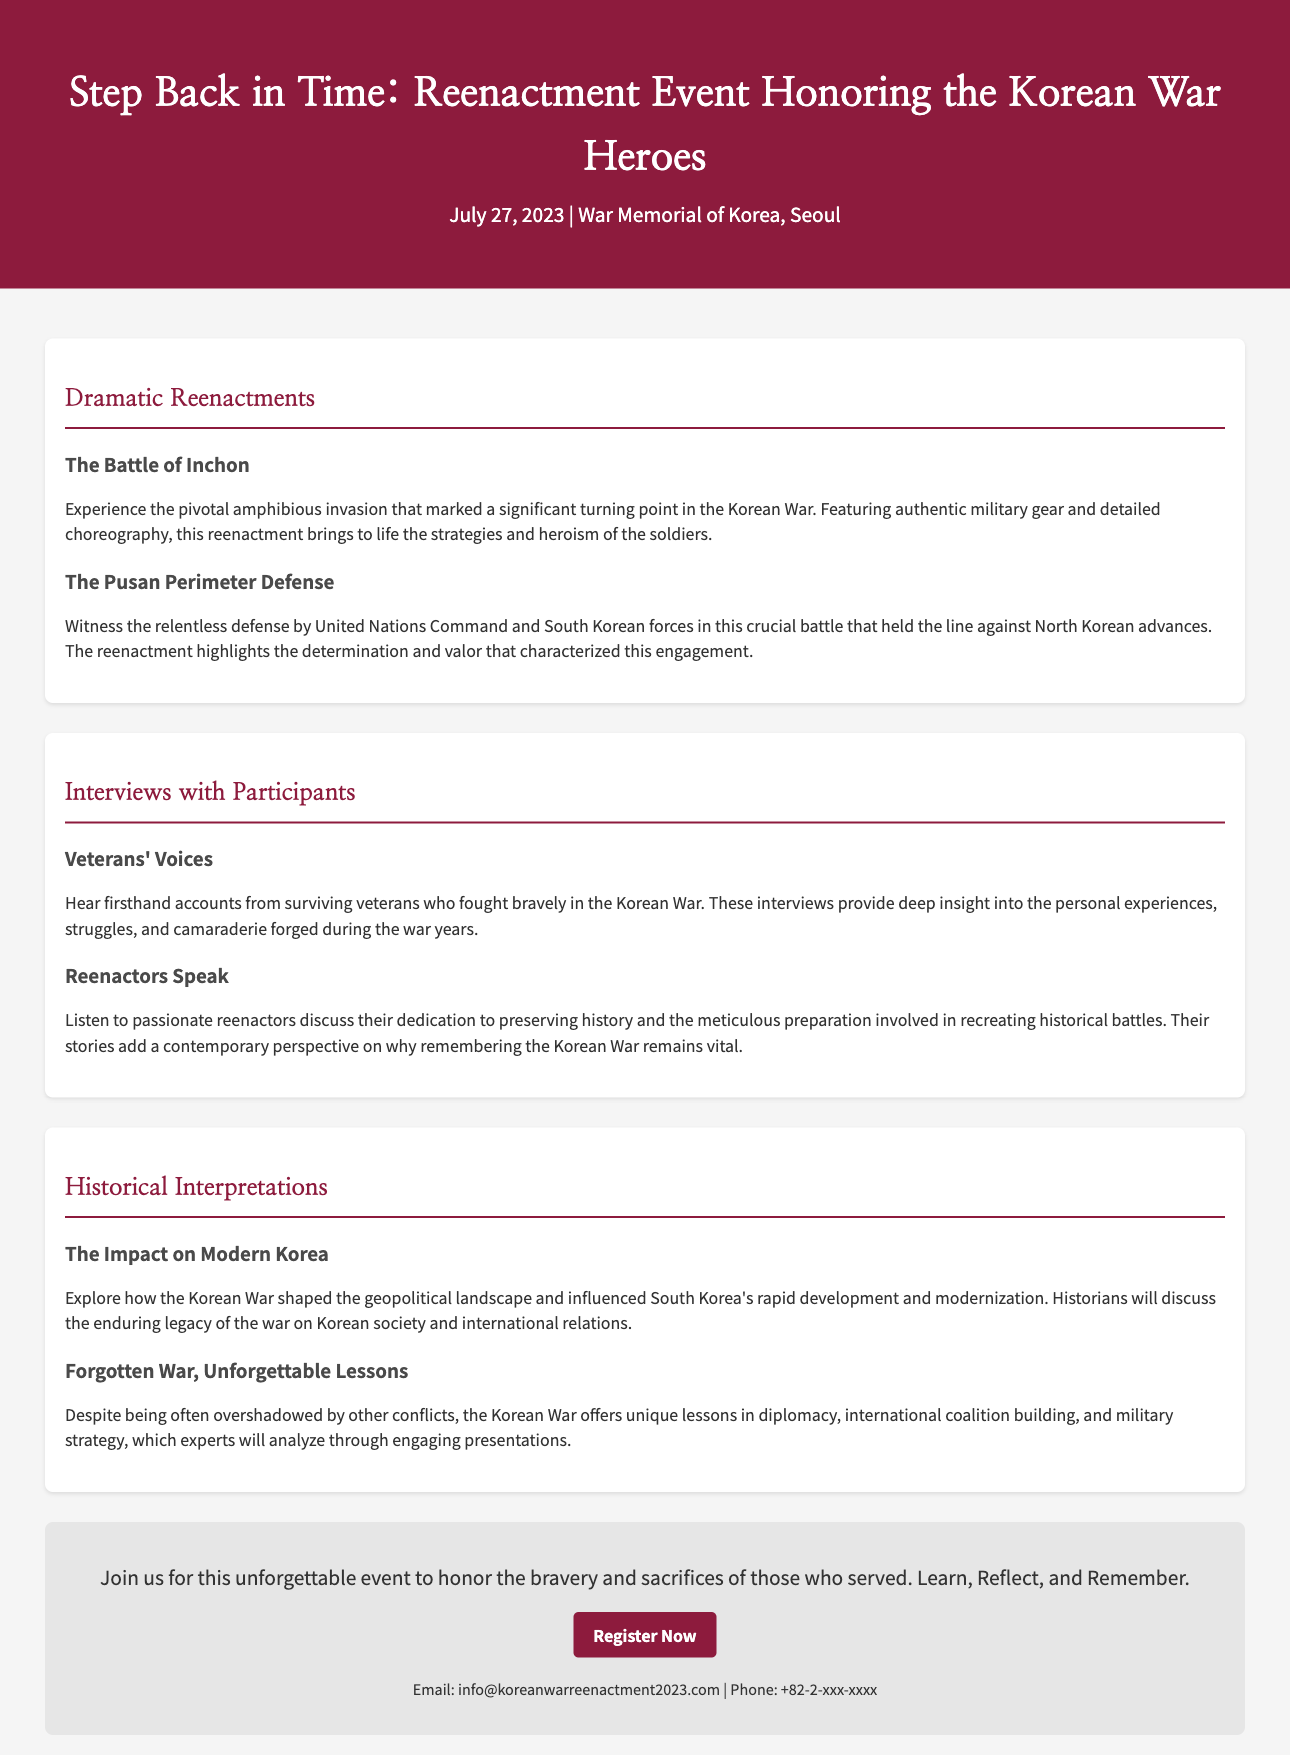What is the title of the event? The title of the event is provided in the header section of the document.
Answer: Step Back in Time: Reenactment Event Honoring the Korean War Heroes When is the event taking place? The date of the event is mentioned in the event-info section.
Answer: July 27, 2023 Where is the event being held? The location of the event is stated in the event-info section.
Answer: War Memorial of Korea, Seoul What battle is featured in the dramatic reenactments? The document lists the battles included in the reenactments.
Answer: The Battle of Inchon Who provides firsthand accounts during the interviews? This information is mentioned in the section about veteran interviews.
Answer: Veterans What key concept does the event aim to highlight? The overall message of the event is highlighted in the call to action section.
Answer: Bravery and sacrifices of those who served Which battle is highlighted for the relentless defense? The document specifically mentions a battle showcasing defense efforts.
Answer: The Pusan Perimeter Defense How does the event interpret the impact on modern Korea? The document provides insights on how the Korean War influenced modern Korea.
Answer: Geopolitical landscape and development What is discussed in the “Forgotten War, Unforgettable Lessons” section? This section analyzes certain lessons derived from the Korean War.
Answer: Diplomacy and military strategy 